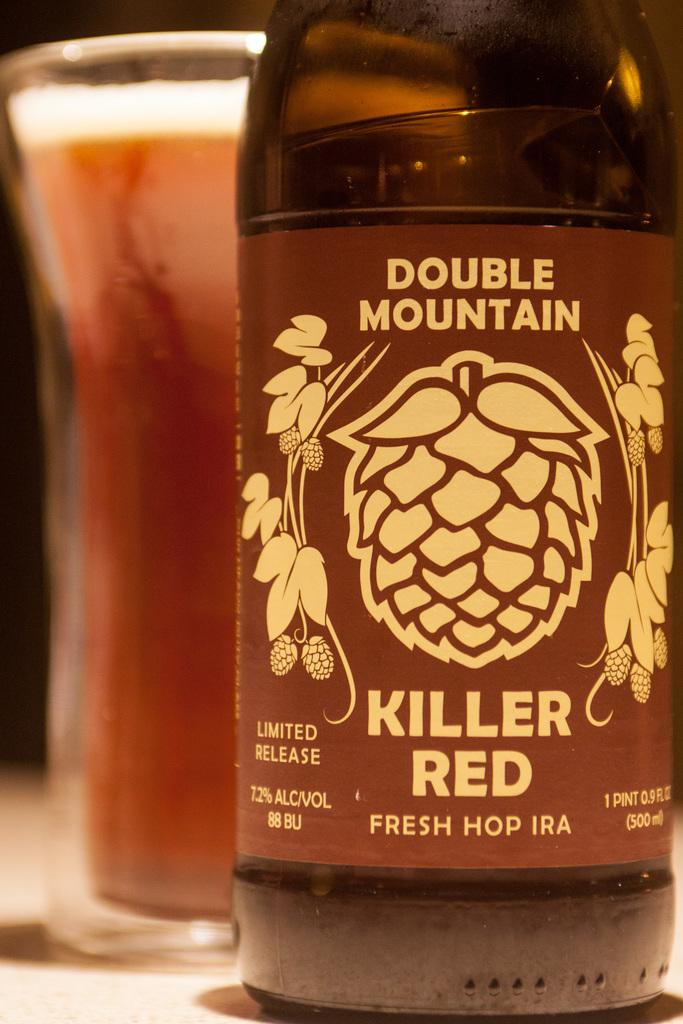Provide a one-sentence caption for the provided image. double mountain brand makes a Killer Red IPA. 